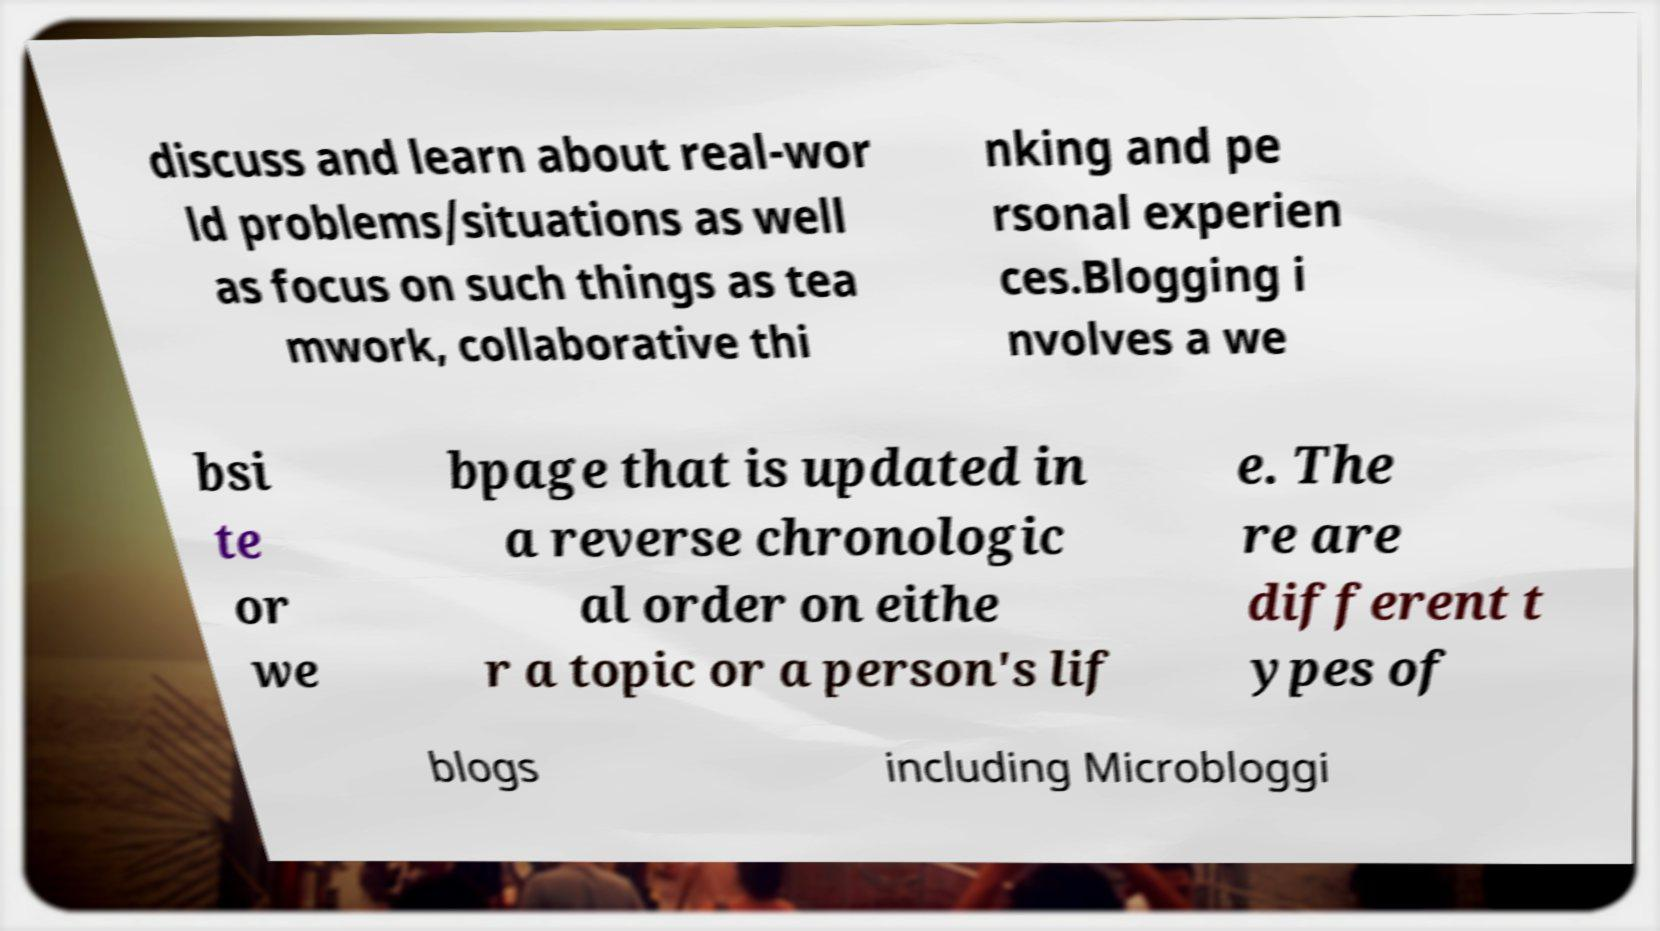Can you accurately transcribe the text from the provided image for me? discuss and learn about real-wor ld problems/situations as well as focus on such things as tea mwork, collaborative thi nking and pe rsonal experien ces.Blogging i nvolves a we bsi te or we bpage that is updated in a reverse chronologic al order on eithe r a topic or a person's lif e. The re are different t ypes of blogs including Microbloggi 